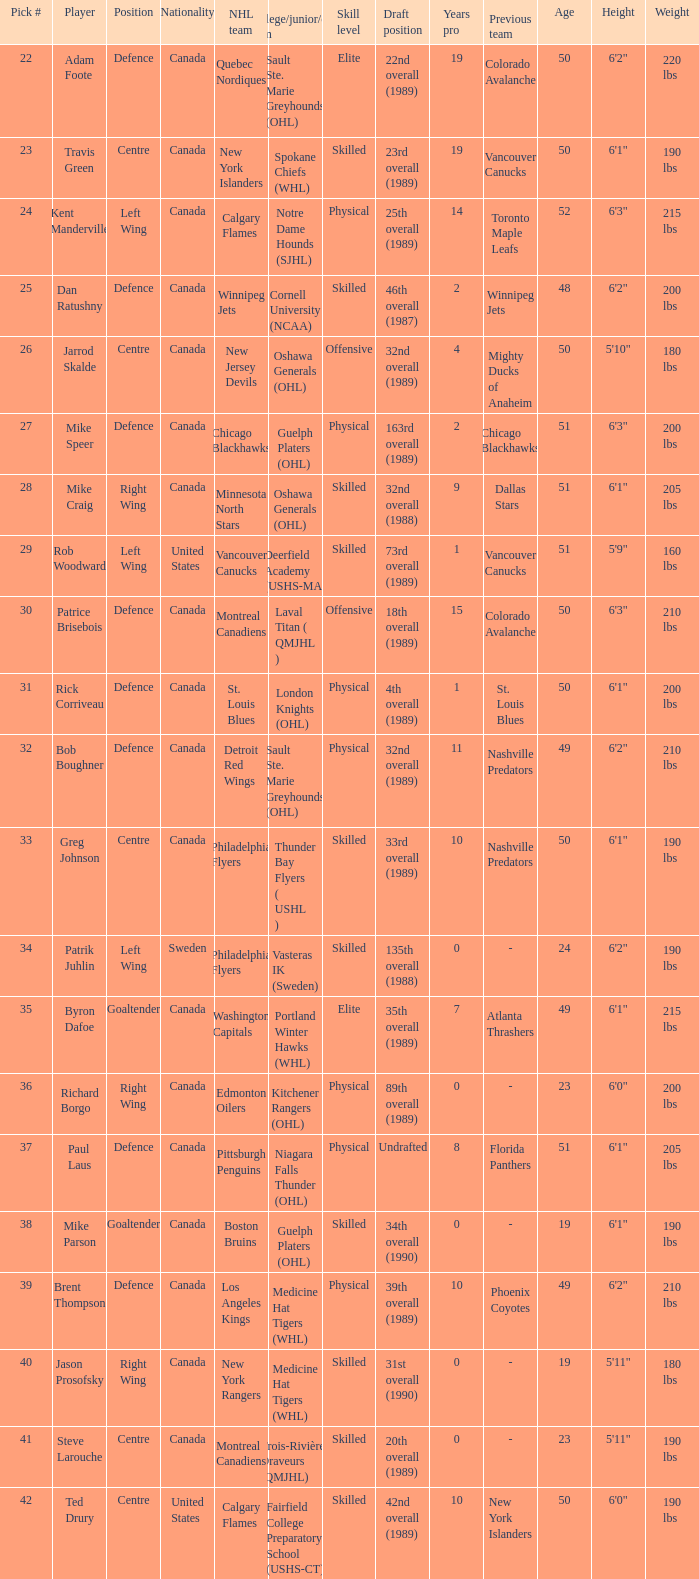I'm looking to parse the entire table for insights. Could you assist me with that? {'header': ['Pick #', 'Player', 'Position', 'Nationality', 'NHL team', 'College/junior/club team', 'Skill level', 'Draft position', 'Years pro', 'Previous team', 'Age', 'Height', 'Weight'], 'rows': [['22', 'Adam Foote', 'Defence', 'Canada', 'Quebec Nordiques', 'Sault Ste. Marie Greyhounds (OHL)', 'Elite', '22nd overall (1989)', '19', 'Colorado Avalanche', '50', '6\'2"', '220 lbs'], ['23', 'Travis Green', 'Centre', 'Canada', 'New York Islanders', 'Spokane Chiefs (WHL)', 'Skilled', '23rd overall (1989)', '19', 'Vancouver Canucks', '50', '6\'1"', '190 lbs'], ['24', 'Kent Manderville', 'Left Wing', 'Canada', 'Calgary Flames', 'Notre Dame Hounds (SJHL)', 'Physical', '25th overall (1989)', '14', 'Toronto Maple Leafs', '52', '6\'3"', '215 lbs'], ['25', 'Dan Ratushny', 'Defence', 'Canada', 'Winnipeg Jets', 'Cornell University (NCAA)', 'Skilled', '46th overall (1987)', '2', 'Winnipeg Jets', '48', '6\'2"', '200 lbs'], ['26', 'Jarrod Skalde', 'Centre', 'Canada', 'New Jersey Devils', 'Oshawa Generals (OHL)', 'Offensive', '32nd overall (1989)', '4', 'Mighty Ducks of Anaheim', '50', '5\'10"', '180 lbs'], ['27', 'Mike Speer', 'Defence', 'Canada', 'Chicago Blackhawks', 'Guelph Platers (OHL)', 'Physical', '163rd overall (1989)', '2', 'Chicago Blackhawks', '51', '6\'3"', '200 lbs'], ['28', 'Mike Craig', 'Right Wing', 'Canada', 'Minnesota North Stars', 'Oshawa Generals (OHL)', 'Skilled', '32nd overall (1988)', '9', 'Dallas Stars', '51', '6\'1"', '205 lbs'], ['29', 'Rob Woodward', 'Left Wing', 'United States', 'Vancouver Canucks', 'Deerfield Academy (USHS-MA)', 'Skilled', '73rd overall (1989)', '1', 'Vancouver Canucks', '51', '5\'9"', '160 lbs'], ['30', 'Patrice Brisebois', 'Defence', 'Canada', 'Montreal Canadiens', 'Laval Titan ( QMJHL )', 'Offensive', '18th overall (1989)', '15', 'Colorado Avalanche', '50', '6\'3"', '210 lbs'], ['31', 'Rick Corriveau', 'Defence', 'Canada', 'St. Louis Blues', 'London Knights (OHL)', 'Physical', '4th overall (1989)', '1', 'St. Louis Blues', '50', '6\'1"', '200 lbs'], ['32', 'Bob Boughner', 'Defence', 'Canada', 'Detroit Red Wings', 'Sault Ste. Marie Greyhounds (OHL)', 'Physical', '32nd overall (1989)', '11', 'Nashville Predators', '49', '6\'2"', '210 lbs'], ['33', 'Greg Johnson', 'Centre', 'Canada', 'Philadelphia Flyers', 'Thunder Bay Flyers ( USHL )', 'Skilled', '33rd overall (1989)', '10', 'Nashville Predators', '50', '6\'1"', '190 lbs'], ['34', 'Patrik Juhlin', 'Left Wing', 'Sweden', 'Philadelphia Flyers', 'Vasteras IK (Sweden)', 'Skilled', '135th overall (1988)', '0', '-', '24', '6\'2"', '190 lbs'], ['35', 'Byron Dafoe', 'Goaltender', 'Canada', 'Washington Capitals', 'Portland Winter Hawks (WHL)', 'Elite', '35th overall (1989)', '7', 'Atlanta Thrashers', '49', '6\'1"', '215 lbs'], ['36', 'Richard Borgo', 'Right Wing', 'Canada', 'Edmonton Oilers', 'Kitchener Rangers (OHL)', 'Physical', '89th overall (1989)', '0', '-', '23', '6\'0"', '200 lbs'], ['37', 'Paul Laus', 'Defence', 'Canada', 'Pittsburgh Penguins', 'Niagara Falls Thunder (OHL)', 'Physical', 'Undrafted', '8', 'Florida Panthers', '51', '6\'1"', '205 lbs'], ['38', 'Mike Parson', 'Goaltender', 'Canada', 'Boston Bruins', 'Guelph Platers (OHL)', 'Skilled', '34th overall (1990)', '0', '-', '19', '6\'1"', '190 lbs'], ['39', 'Brent Thompson', 'Defence', 'Canada', 'Los Angeles Kings', 'Medicine Hat Tigers (WHL)', 'Physical', '39th overall (1989)', '10', 'Phoenix Coyotes', '49', '6\'2"', '210 lbs'], ['40', 'Jason Prosofsky', 'Right Wing', 'Canada', 'New York Rangers', 'Medicine Hat Tigers (WHL)', 'Skilled', '31st overall (1990)', '0', '-', '19', '5\'11"', '180 lbs'], ['41', 'Steve Larouche', 'Centre', 'Canada', 'Montreal Canadiens', 'Trois-Rivières Draveurs (QMJHL)', 'Skilled', '20th overall (1989)', '0', '-', '23', '5\'11"', '190 lbs'], ['42', 'Ted Drury', 'Centre', 'United States', 'Calgary Flames', 'Fairfield College Preparatory School (USHS-CT)', 'Skilled', '42nd overall (1989)', '10', 'New York Islanders', '50', '6\'0"', '190 lbs']]} What NHL team picked richard borgo? Edmonton Oilers. 